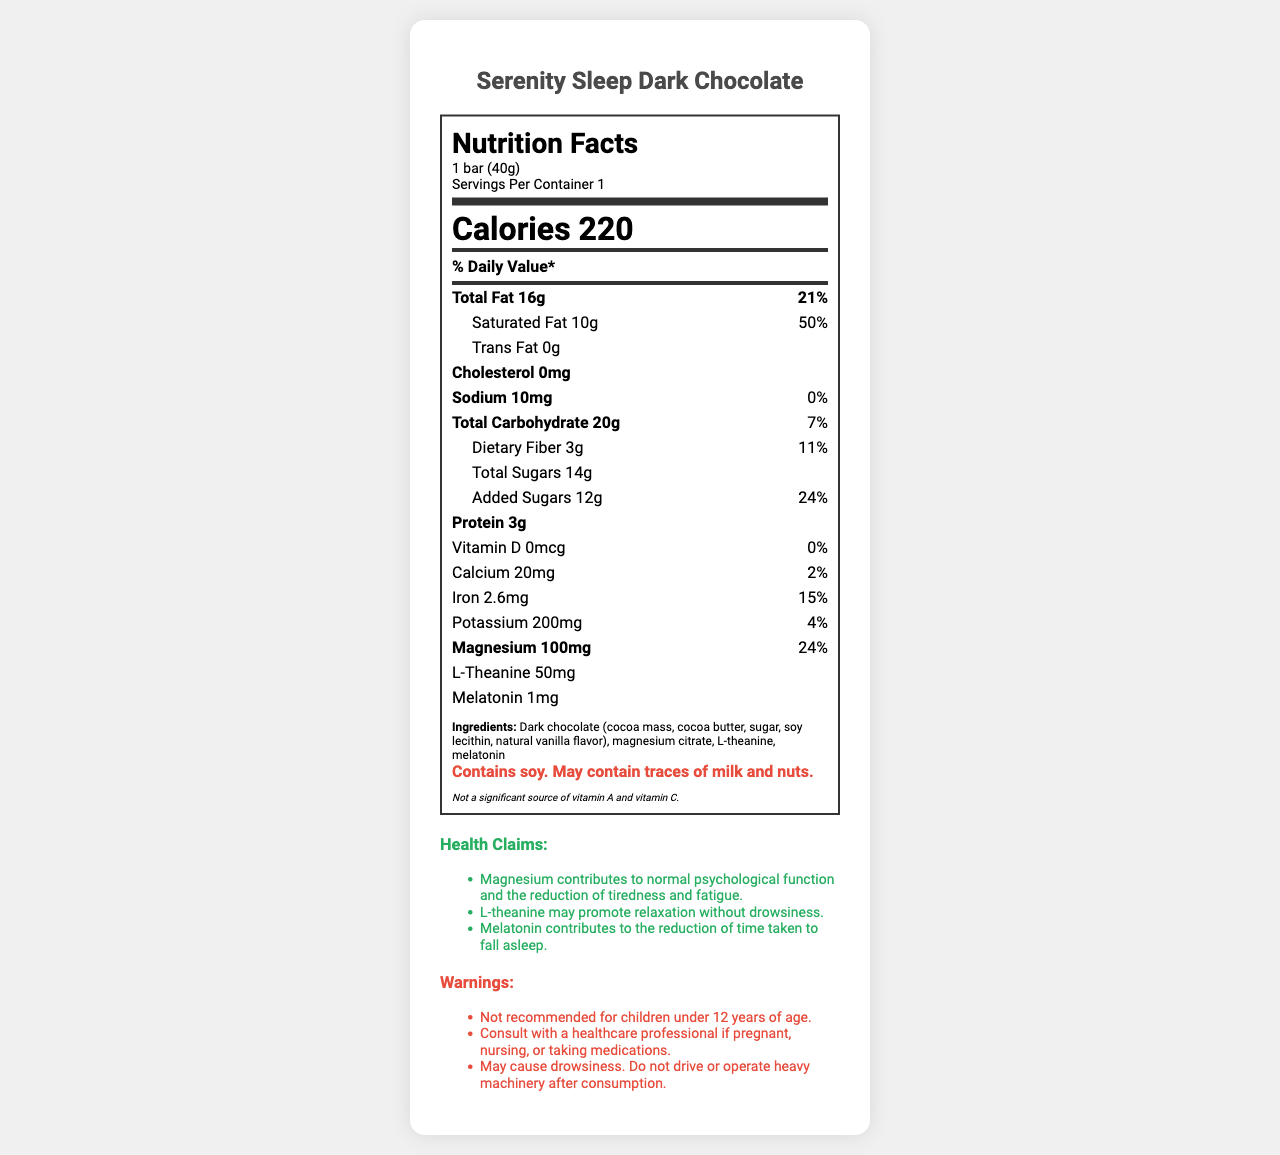what is the serving size of the Serenity Sleep Dark Chocolate? The serving size is specifically mentioned as "1 bar (40g)" near the top of the Nutrition Facts label.
Answer: 1 bar (40g) how many calories are in one serving? The document clearly states "Calories 220" under the serving information.
Answer: 220 what percentage of Daily Value (%DV) of magnesium does one serving provide? The %DV for magnesium is noted as 24% in the nutrition facts section.
Answer: 24% how much L-theanine is in one serving? The amount of L-theanine is shown as "L-Theanine 50mg."
Answer: 50mg does the product contain any trans fat? The document states "Trans Fat 0g" under the fat section.
Answer: No what are the main ingredients of the Serenity Sleep Dark Chocolate? The ingredients are listed in the ingredients section.
Answer: Dark chocolate (cocoa mass, cocoa butter, sugar, soy lecithin, natural vanilla flavor), magnesium citrate, L-theanine, melatonin which nutrient contributes the most to the % Daily Value (%DV) per serving? A. Saturated Fat B. Magnesium C. Iron D. Sodium The %DV for Saturated Fat is 50%, which is higher than any other listed nutrient.
Answer: A. Saturated Fat what is the suggested usage instruction for this product? A. Consume any time during the day B. Consume 1-2 hours before bedtime C. Consume with meals D. Consume immediately after waking up The usage instructions specify, "Consume 1-2 hours before bedtime as part of a relaxing evening routine."
Answer: B. Consume 1-2 hours before bedtime is this product recommended for children under 12 years of age? One of the warnings clearly states, "Not recommended for children under 12 years of age."
Answer: No how should Serenity Sleep Dark Chocolate be stored? The storage instructions are listed at the end of the document.
Answer: Store in a cool, dry place away from direct sunlight can it be determined if this product is suitable for someone with a nut allergy? The label states it "May contain traces of milk and nuts," which means there's a risk of nut contamination.
Answer: Cannot be determined summarize the main idea of the Nutrition Facts label for Serenity Sleep Dark Chocolate. The summary explains the key points covered in the nutrition label and other related sections, encapsulating the main purpose and features of the product in a concise manner.
Answer: The Nutrition Facts label for Serenity Sleep Dark Chocolate provides detailed information about its serving size, calories, nutrients, and specific ingredients. It also includes health claims related to relaxation and sleep, warnings about its use, and storage instructions. The product is fortified with magnesium, L-theanine, and melatonin to promote relaxation and sleep quality. 